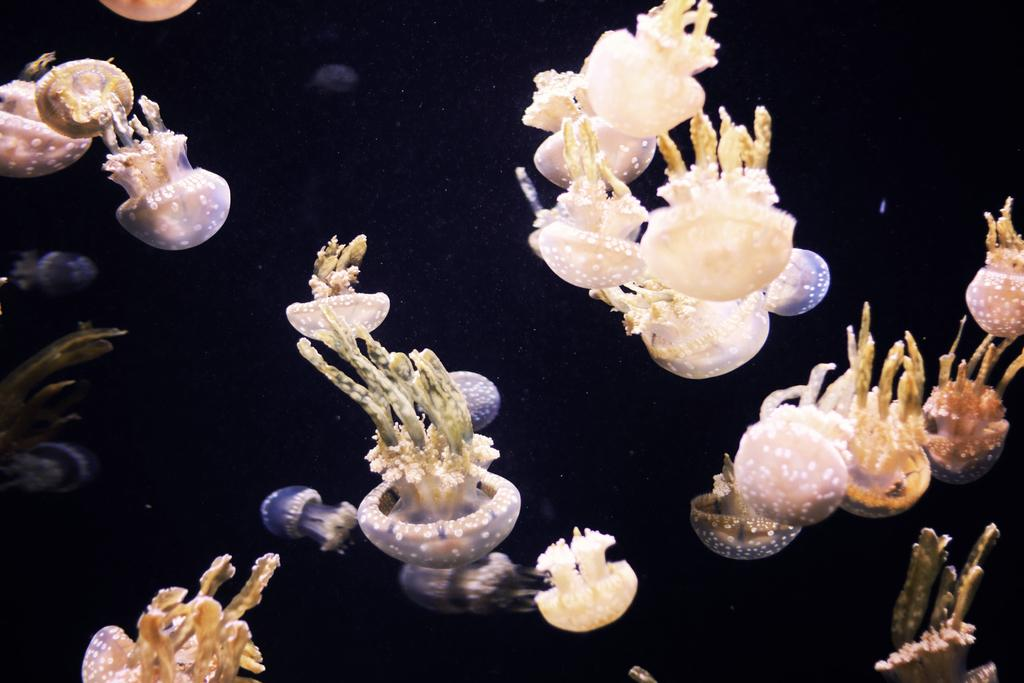What type of plants are visible in the image? There are water plants in the image. What can be observed about the background of the image? The background of the image is dark. What type of furniture is present in the image? There is no furniture present in the image; it features water plants and a dark background. What note can be seen in the image? There is no note visible in the image. 